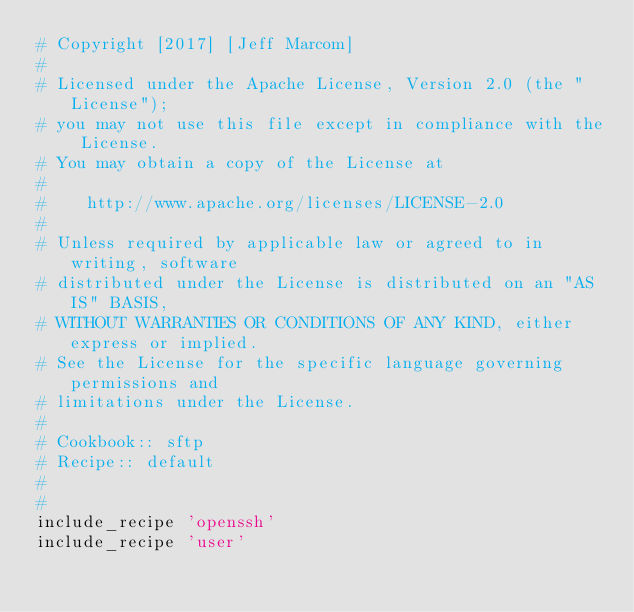<code> <loc_0><loc_0><loc_500><loc_500><_Ruby_># Copyright [2017] [Jeff Marcom]
#
# Licensed under the Apache License, Version 2.0 (the "License");
# you may not use this file except in compliance with the License.
# You may obtain a copy of the License at
#
#    http://www.apache.org/licenses/LICENSE-2.0
#
# Unless required by applicable law or agreed to in writing, software
# distributed under the License is distributed on an "AS IS" BASIS,
# WITHOUT WARRANTIES OR CONDITIONS OF ANY KIND, either express or implied.
# See the License for the specific language governing permissions and
# limitations under the License.
#
# Cookbook:: sftp
# Recipe:: default
#
#
include_recipe 'openssh'
include_recipe 'user'
</code> 